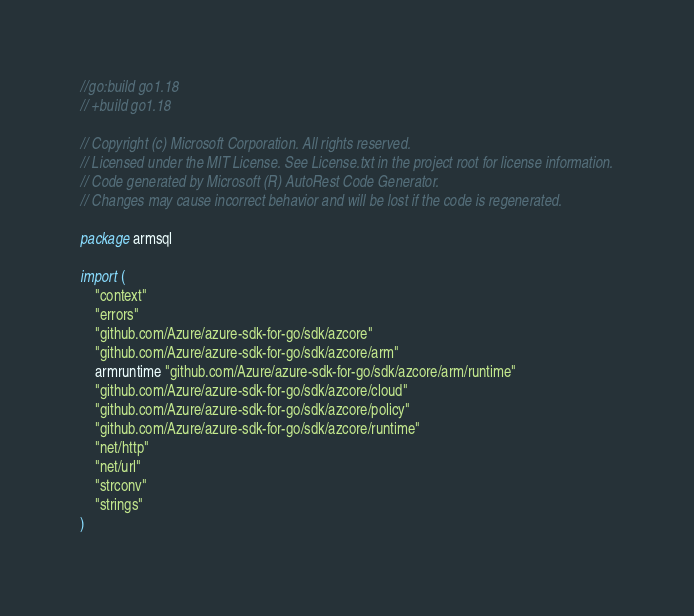<code> <loc_0><loc_0><loc_500><loc_500><_Go_>//go:build go1.18
// +build go1.18

// Copyright (c) Microsoft Corporation. All rights reserved.
// Licensed under the MIT License. See License.txt in the project root for license information.
// Code generated by Microsoft (R) AutoRest Code Generator.
// Changes may cause incorrect behavior and will be lost if the code is regenerated.

package armsql

import (
	"context"
	"errors"
	"github.com/Azure/azure-sdk-for-go/sdk/azcore"
	"github.com/Azure/azure-sdk-for-go/sdk/azcore/arm"
	armruntime "github.com/Azure/azure-sdk-for-go/sdk/azcore/arm/runtime"
	"github.com/Azure/azure-sdk-for-go/sdk/azcore/cloud"
	"github.com/Azure/azure-sdk-for-go/sdk/azcore/policy"
	"github.com/Azure/azure-sdk-for-go/sdk/azcore/runtime"
	"net/http"
	"net/url"
	"strconv"
	"strings"
)
</code> 